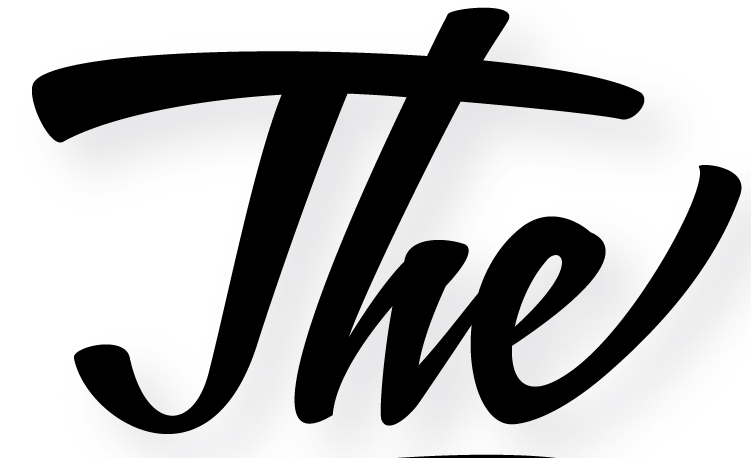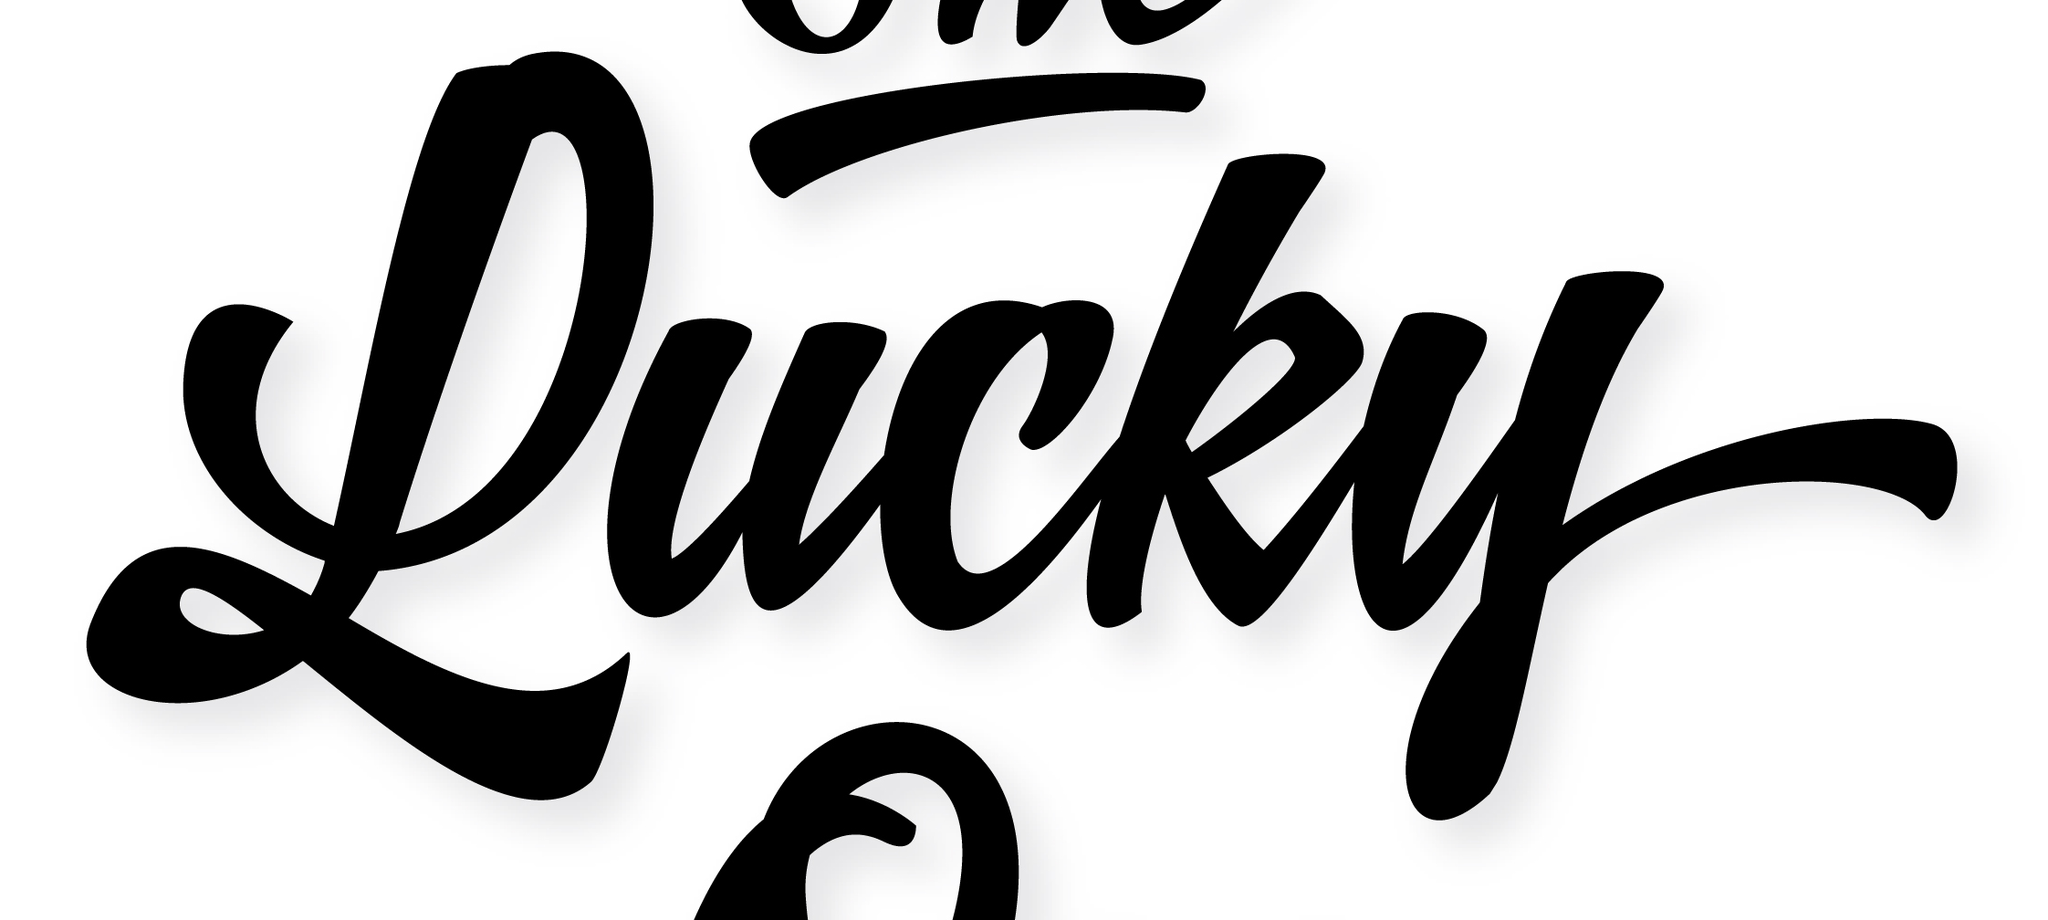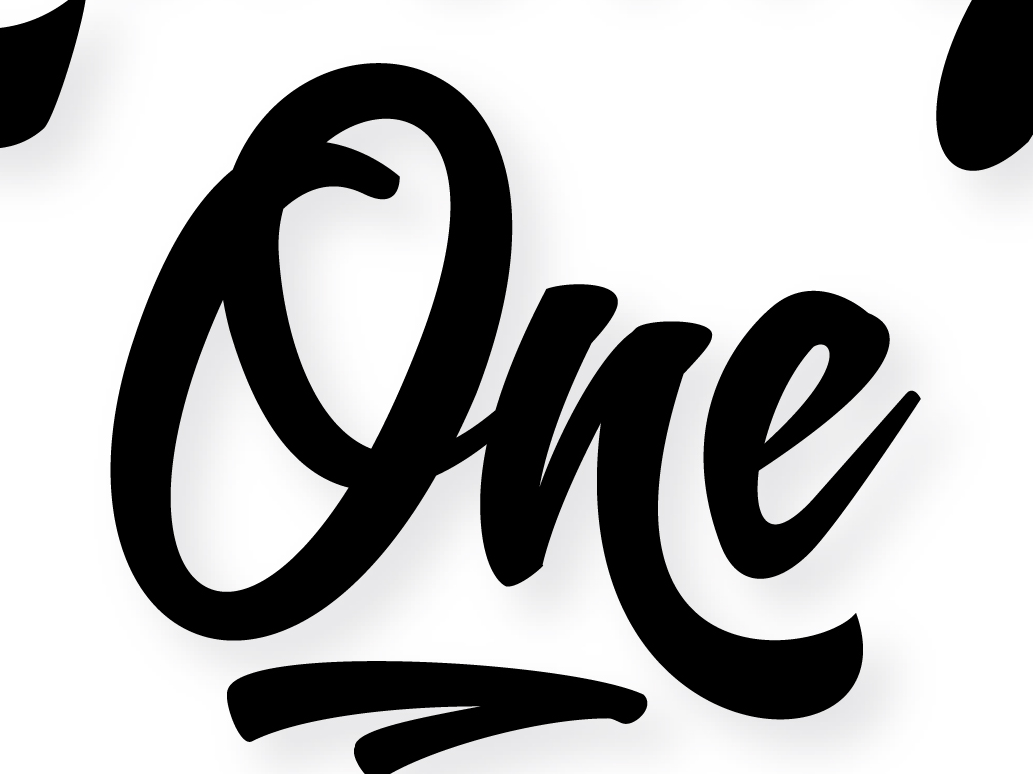What words can you see in these images in sequence, separated by a semicolon? The; Lucky; One 